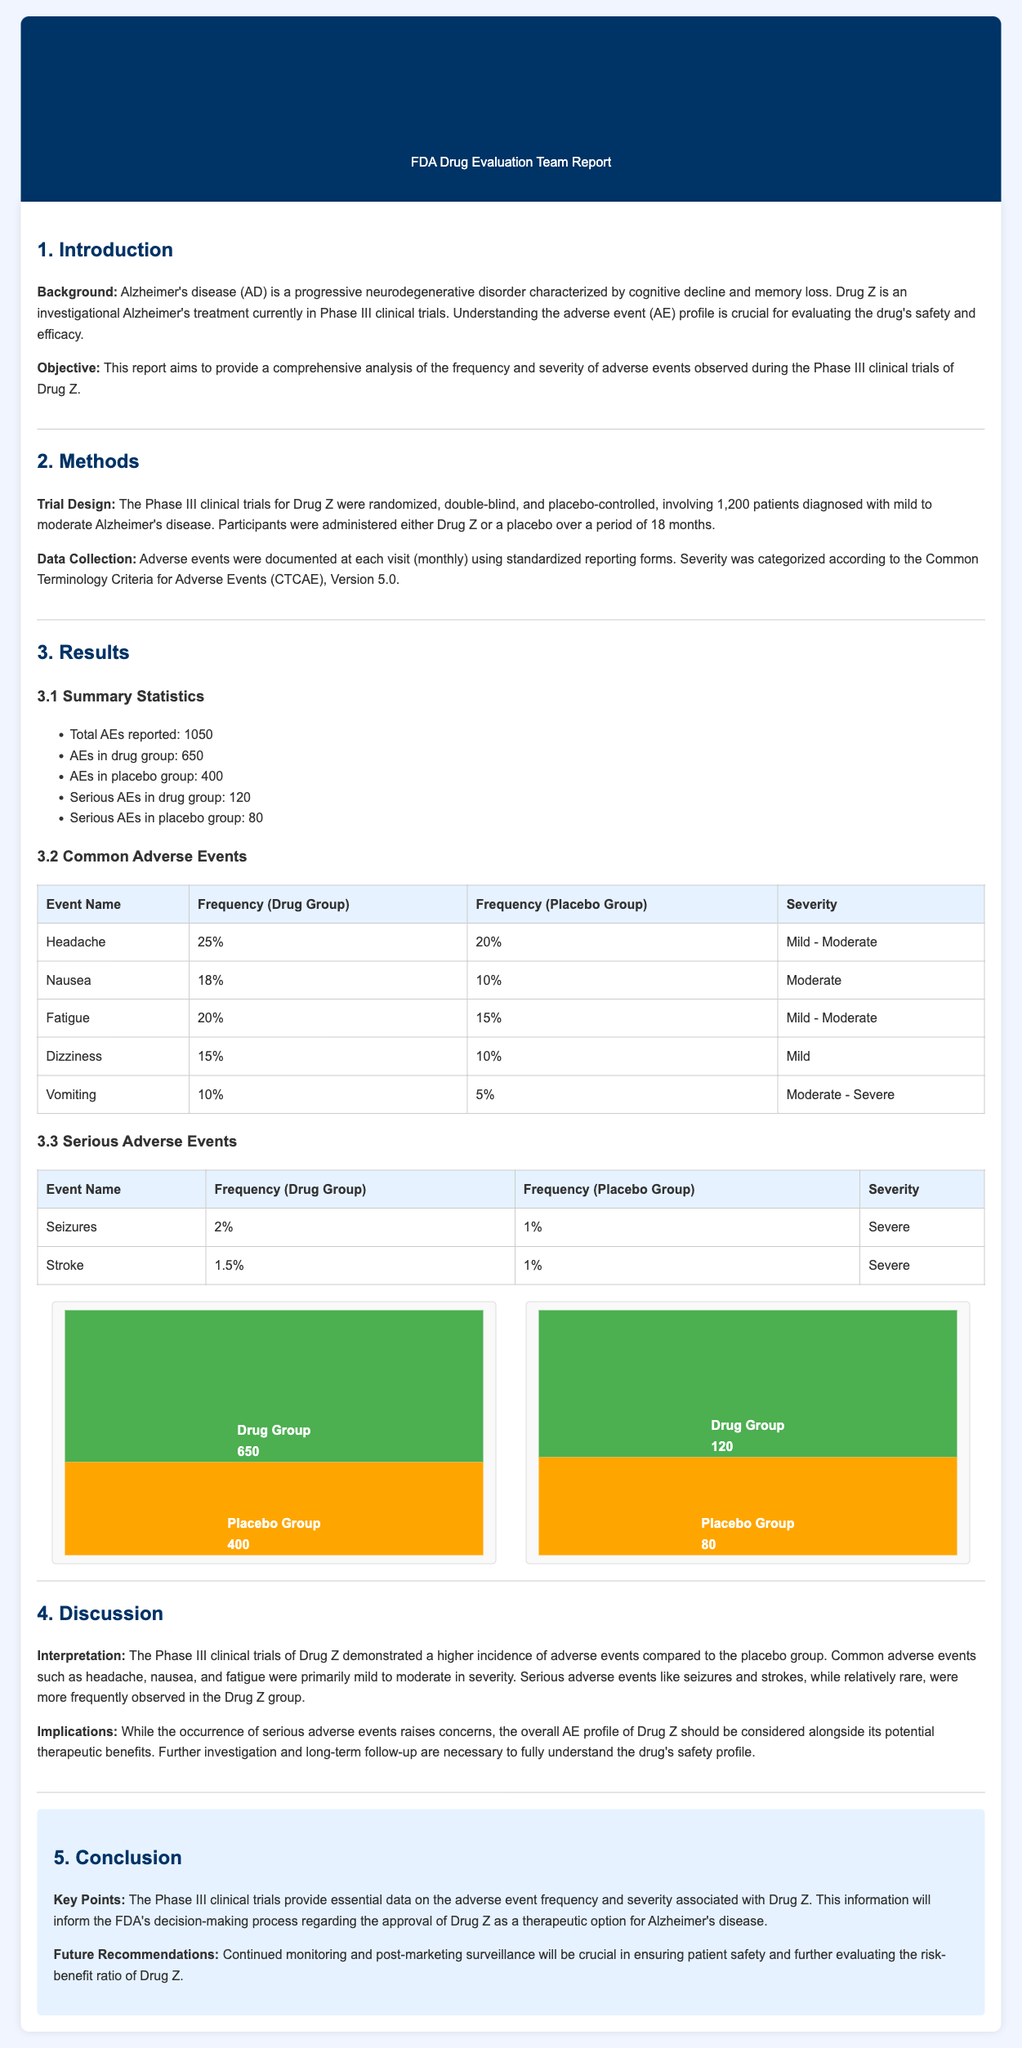What is the total number of AEs reported? The total number of adverse events reported in the trials is stated as 1,050.
Answer: 1,050 What percentage of patients in the drug group experienced headaches? The document specifies that 25% of patients in the drug group reported headaches.
Answer: 25% How many serious AEs were reported in the placebo group? The report indicates that there were 80 serious adverse events reported in the placebo group.
Answer: 80 What is the severity of the common adverse event 'Nausea'? According to the report, the severity of nausea is classified as moderate.
Answer: Moderate Which serious AE was reported at a frequency of 2% in the drug group? The report lists seizures as the serious adverse event occurring at a frequency of 2% in the drug group.
Answer: Seizures What implications are noted regarding the occurrence of serious AEs? The document mentions that the occurrence of serious adverse events raises concerns regarding the drug's safety profile.
Answer: Raises concerns What is the total number of patients involved in the Phase III clinical trials? The report specifies that there were 1,200 patients involved in the Phase III clinical trials.
Answer: 1,200 What overall conclusion is drawn about drug Z in the trials? The conclusion states that the trials provide essential data on the adverse event frequency and severity associated with Drug Z.
Answer: Essential data on adverse events What are the future recommendations for Drug Z? The report recommends continued monitoring and post-marketing surveillance to ensure patient safety.
Answer: Continued monitoring and post-marketing surveillance 